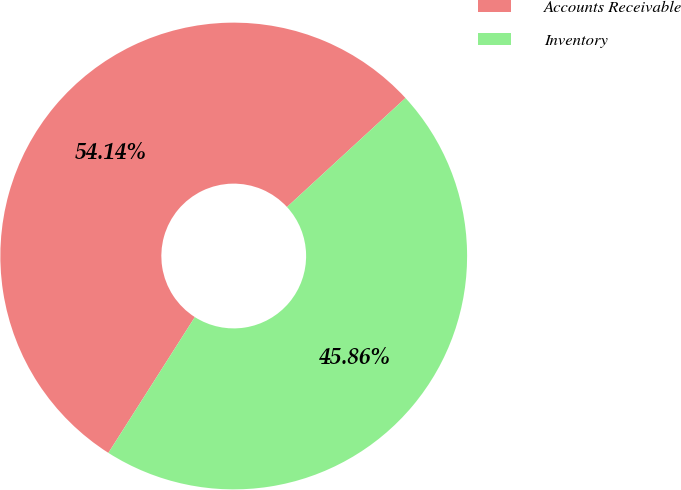<chart> <loc_0><loc_0><loc_500><loc_500><pie_chart><fcel>Accounts Receivable<fcel>Inventory<nl><fcel>54.14%<fcel>45.86%<nl></chart> 